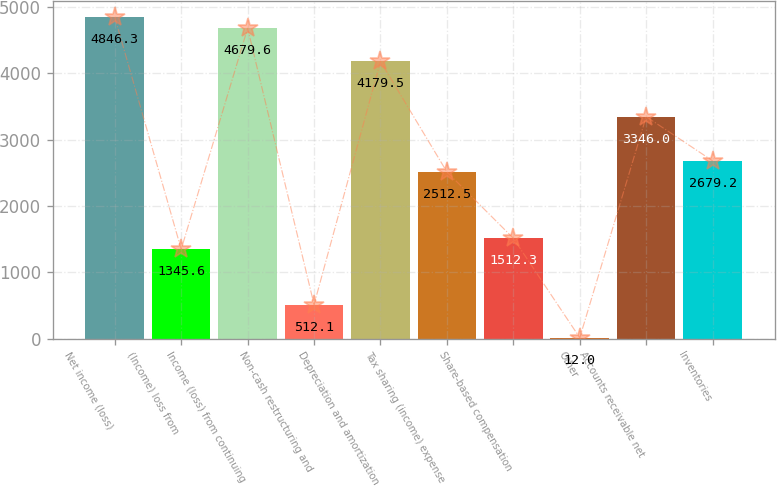<chart> <loc_0><loc_0><loc_500><loc_500><bar_chart><fcel>Net income (loss)<fcel>(Income) loss from<fcel>Income (loss) from continuing<fcel>Non-cash restructuring and<fcel>Depreciation and amortization<fcel>Tax sharing (income) expense<fcel>Share-based compensation<fcel>Other<fcel>Accounts receivable net<fcel>Inventories<nl><fcel>4846.3<fcel>1345.6<fcel>4679.6<fcel>512.1<fcel>4179.5<fcel>2512.5<fcel>1512.3<fcel>12<fcel>3346<fcel>2679.2<nl></chart> 